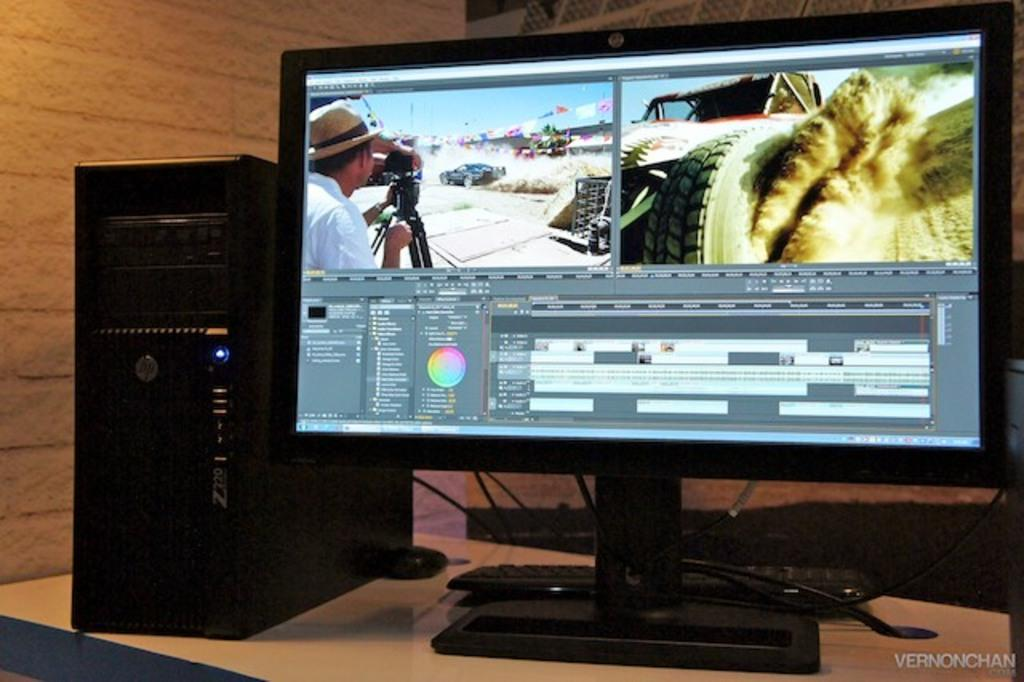What electronic device is on the table in the image? There is a computer on the table in the image. What is located beside the computer? There is a CPU beside the computer. What input devices are visible in the background of the image? In the background, there is a keyboard and a mouse on the table. What can be seen on the computer's desktop? There are pictures visible on the computer's desktop. What type of fowl is sitting on the computer in the image? There is no fowl present in the image; it is a computer on a table with related devices. 